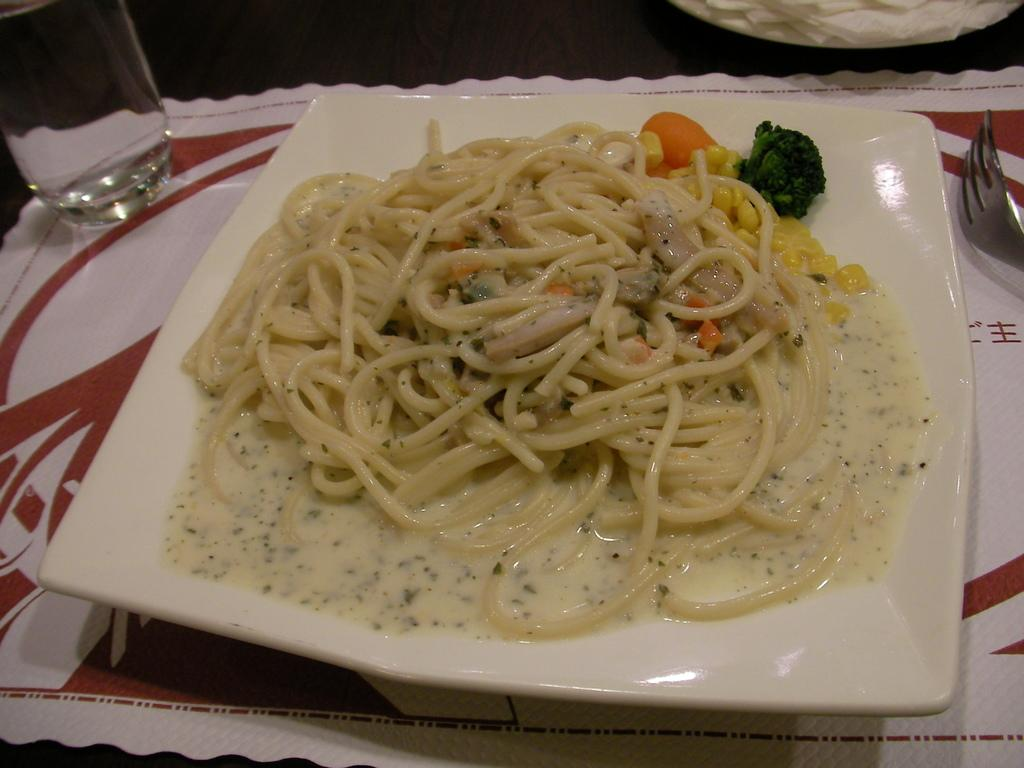What piece of furniture is present in the image? There is a table in the image. What is on the table? There is a plate containing food, a glass, tissue paper, a napkin, and a fork on the table. What might be used for drinking in the image? There is a glass on the table. What might be used for cleaning or wiping in the image? There is tissue paper and a napkin on the table. What utensil is placed on the table? There is a fork placed on the table. What type of knot is tied on the table in the image? There is no knot present on the table in the image. What type of mark can be seen on the plate in the image? There is no mark visible on the plate in the image. 